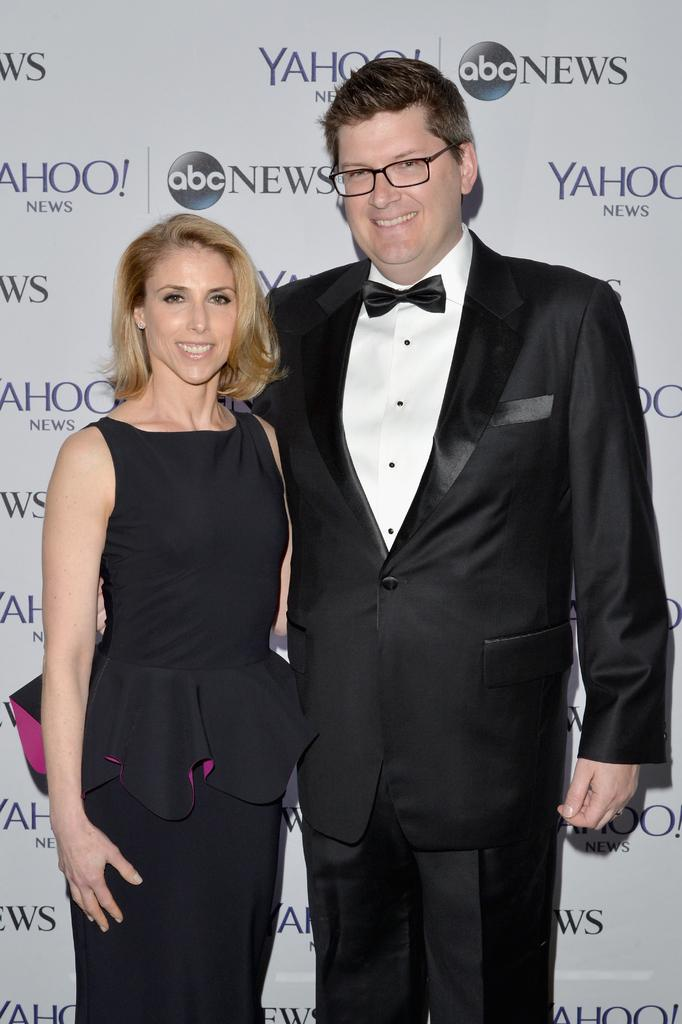<image>
Present a compact description of the photo's key features. A man and woman dressed in formal clothes standing in front of abc News and Yahoo signage. 